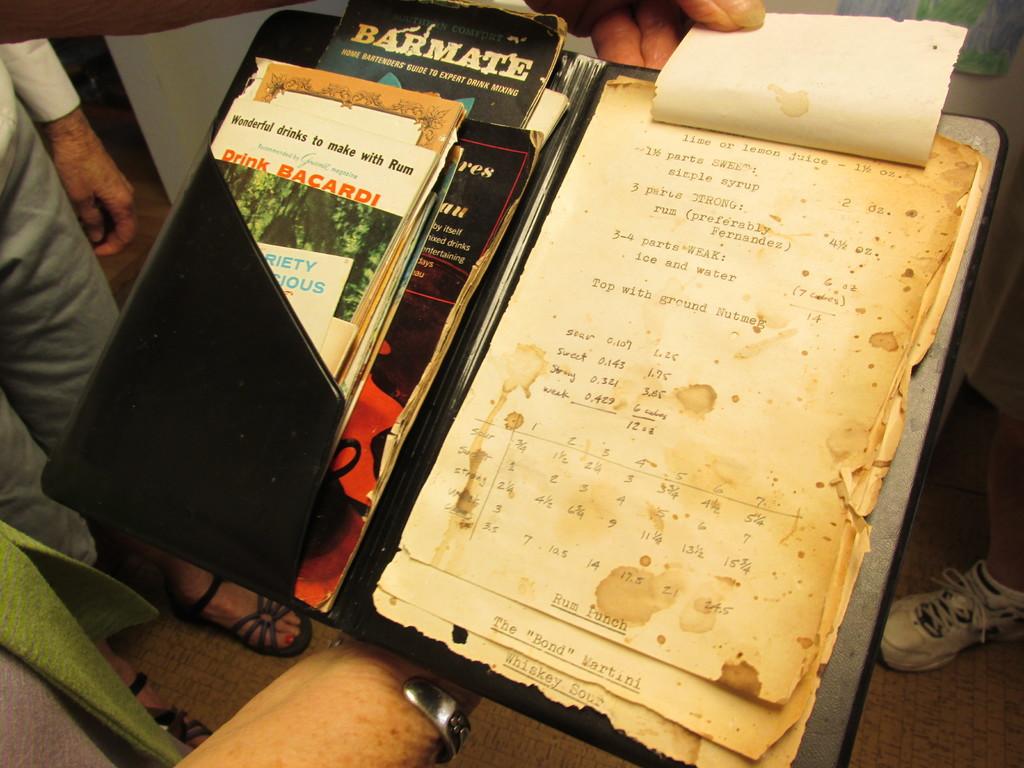What should you drink, according to the words in orange?
Give a very brief answer. Bacardi. 